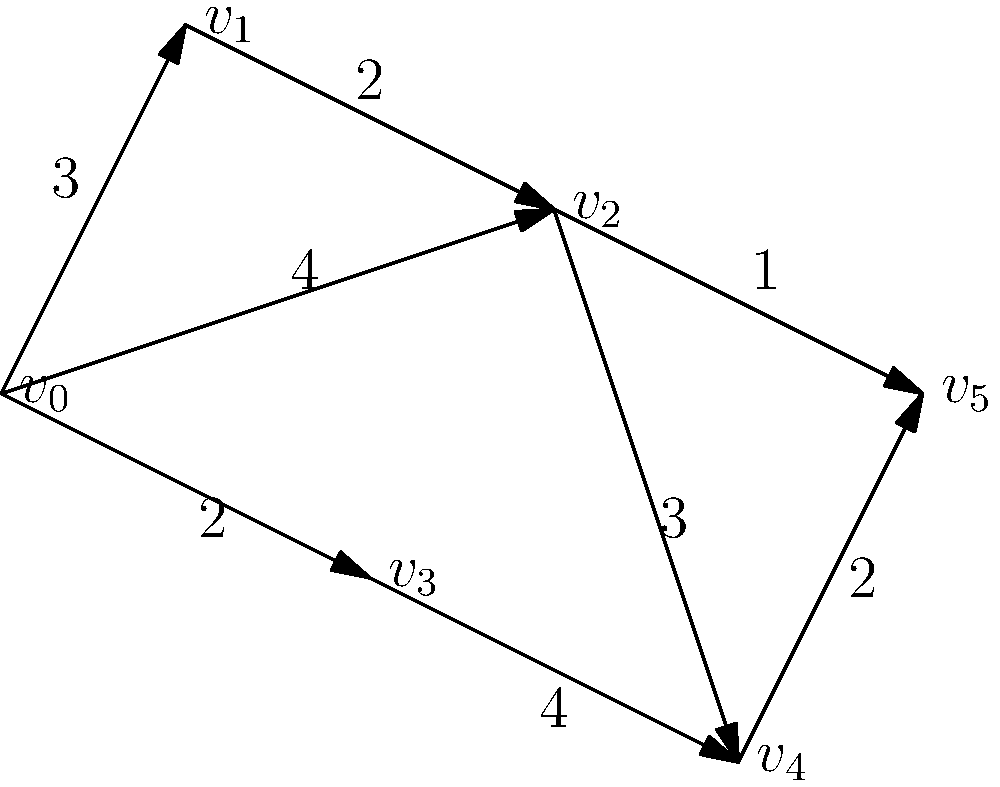Given the weighted graph representing crime hotspots in an urban area, where vertices represent locations and edge weights represent the risk level of criminal activity between locations, determine the shortest path from $v_0$ to $v_5$ using Dijkstra's algorithm. What is the total risk level (sum of edge weights) along this path? To solve this problem using Dijkstra's algorithm, we'll follow these steps:

1) Initialize:
   - Set distance to $v_0$ as 0 and all others as infinity.
   - Set all nodes as unvisited.
   - Set $v_0$ as the current node.

2) For the current node, consider all unvisited neighbors and calculate their tentative distances.
   - For $v_0$: Update $v_1$ (3), $v_2$ (4), and $v_3$ (2).

3) Mark current node as visited. Select the unvisited node with the smallest tentative distance as the new current node.
   - Mark $v_0$ as visited. New current node: $v_3$ (distance 2).

4) Repeat steps 2-3:
   - For $v_3$: Update $v_4$ (2+4=6).
   - Mark $v_3$ as visited. New current node: $v_1$ (distance 3).
   - For $v_1$: Update $v_2$ (3+2=5, better than current 4).
   - Mark $v_1$ as visited. New current node: $v_2$ (distance 4).
   - For $v_2$: Update $v_4$ (4+3=7, not better) and $v_5$ (4+1=5).
   - Mark $v_2$ as visited. New current node: $v_5$ (distance 5).

5) The algorithm terminates as we've reached $v_5$.

The shortest path is $v_0 \rightarrow v_2 \rightarrow v_5$ with a total risk level of 4 + 1 = 5.
Answer: 5 